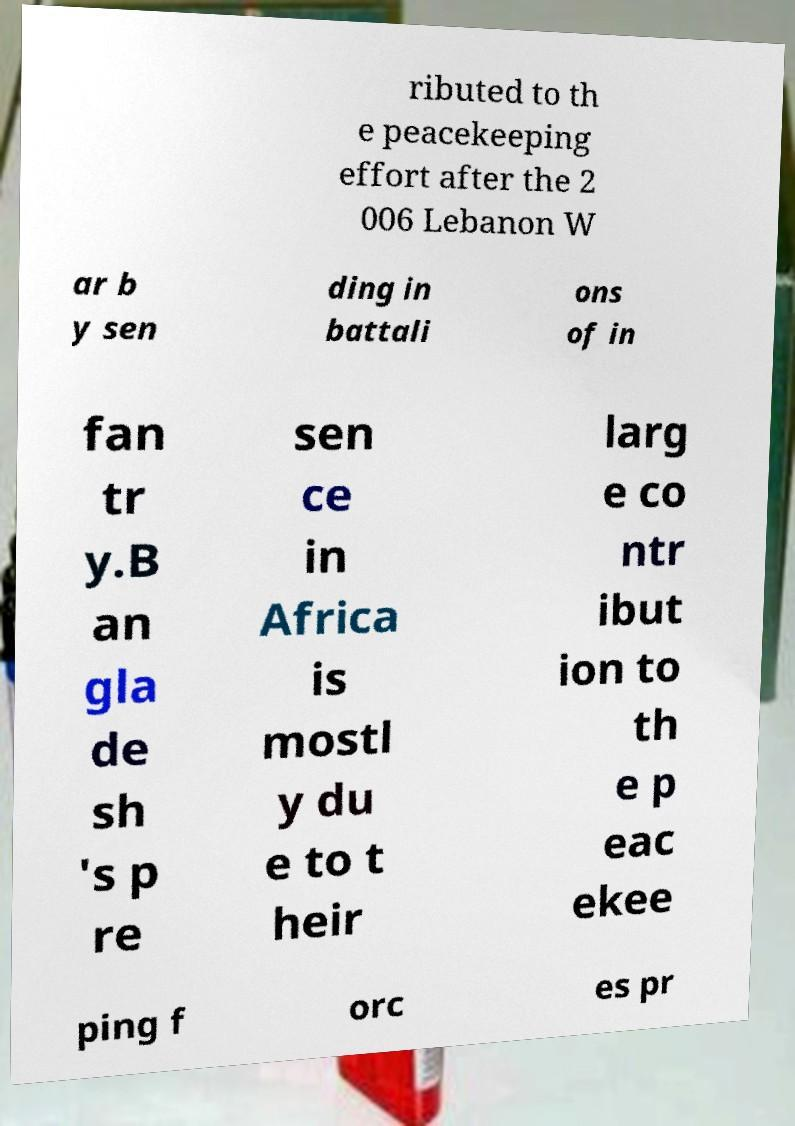What messages or text are displayed in this image? I need them in a readable, typed format. ributed to th e peacekeeping effort after the 2 006 Lebanon W ar b y sen ding in battali ons of in fan tr y.B an gla de sh 's p re sen ce in Africa is mostl y du e to t heir larg e co ntr ibut ion to th e p eac ekee ping f orc es pr 